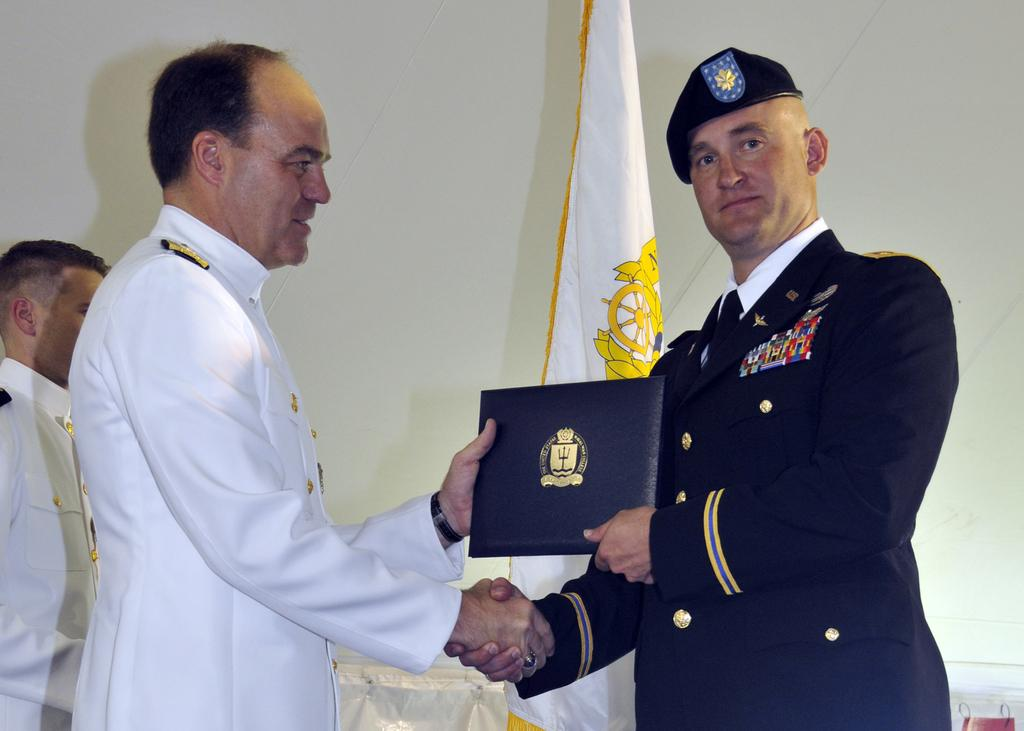How many people are present in the image? There are three people in the image. What are the two men doing in the image? The two men are shaking hands and smiling. What are the two men holding in the image? The two men are holding the same object. What can be seen in the background of the image? There is a wall, a cloth, and a flag in the background of the image. What type of locket is hanging from the flag in the image? There is no locket present in the image, and the flag is not mentioned as having any additional objects hanging from it. 